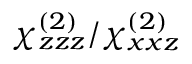Convert formula to latex. <formula><loc_0><loc_0><loc_500><loc_500>\chi _ { z z z } ^ { ( 2 ) } / \chi _ { x x z } ^ { ( 2 ) }</formula> 